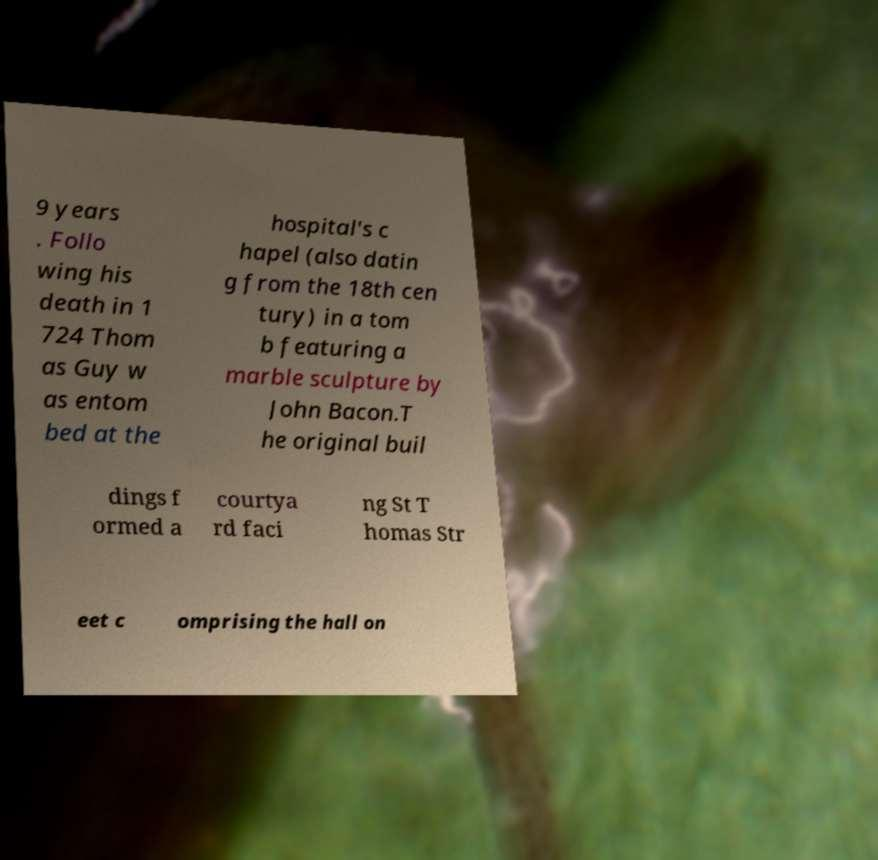Can you accurately transcribe the text from the provided image for me? 9 years . Follo wing his death in 1 724 Thom as Guy w as entom bed at the hospital's c hapel (also datin g from the 18th cen tury) in a tom b featuring a marble sculpture by John Bacon.T he original buil dings f ormed a courtya rd faci ng St T homas Str eet c omprising the hall on 